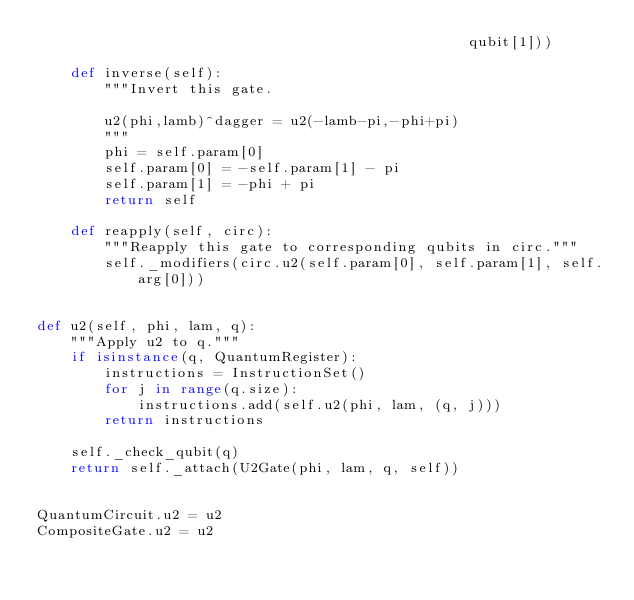Convert code to text. <code><loc_0><loc_0><loc_500><loc_500><_Python_>                                                   qubit[1]))

    def inverse(self):
        """Invert this gate.

        u2(phi,lamb)^dagger = u2(-lamb-pi,-phi+pi)
        """
        phi = self.param[0]
        self.param[0] = -self.param[1] - pi
        self.param[1] = -phi + pi
        return self

    def reapply(self, circ):
        """Reapply this gate to corresponding qubits in circ."""
        self._modifiers(circ.u2(self.param[0], self.param[1], self.arg[0]))


def u2(self, phi, lam, q):
    """Apply u2 to q."""
    if isinstance(q, QuantumRegister):
        instructions = InstructionSet()
        for j in range(q.size):
            instructions.add(self.u2(phi, lam, (q, j)))
        return instructions

    self._check_qubit(q)
    return self._attach(U2Gate(phi, lam, q, self))


QuantumCircuit.u2 = u2
CompositeGate.u2 = u2
</code> 